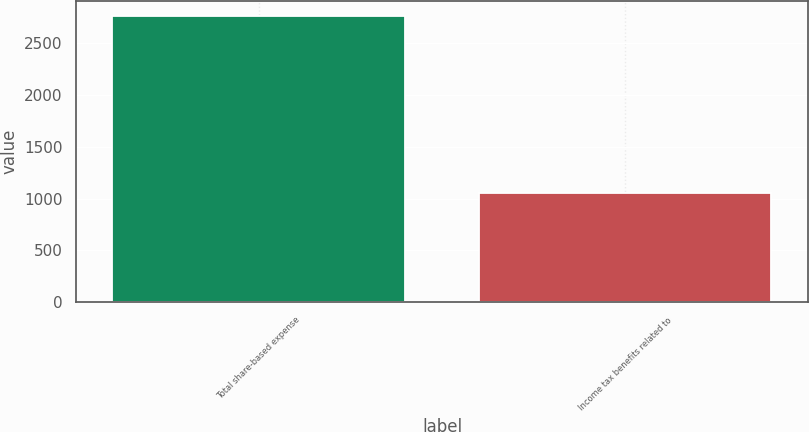Convert chart. <chart><loc_0><loc_0><loc_500><loc_500><bar_chart><fcel>Total share-based expense<fcel>Income tax benefits related to<nl><fcel>2763<fcel>1050<nl></chart> 